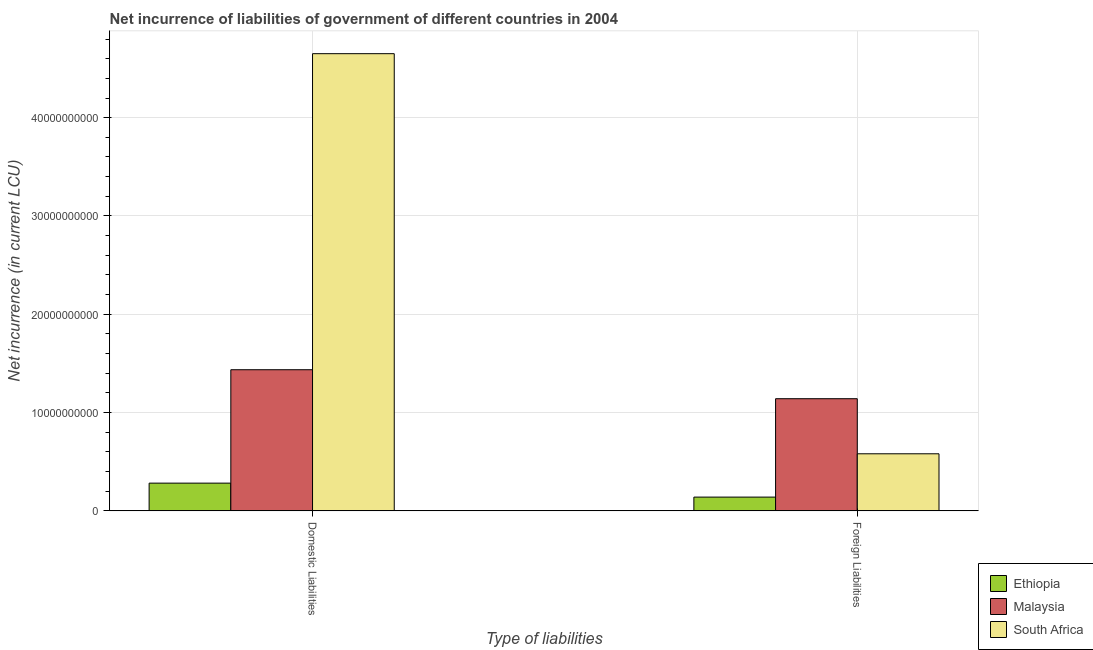How many groups of bars are there?
Give a very brief answer. 2. What is the label of the 2nd group of bars from the left?
Make the answer very short. Foreign Liabilities. What is the net incurrence of domestic liabilities in Malaysia?
Provide a succinct answer. 1.44e+1. Across all countries, what is the maximum net incurrence of foreign liabilities?
Your response must be concise. 1.14e+1. Across all countries, what is the minimum net incurrence of foreign liabilities?
Ensure brevity in your answer.  1.40e+09. In which country was the net incurrence of domestic liabilities maximum?
Offer a terse response. South Africa. In which country was the net incurrence of foreign liabilities minimum?
Provide a short and direct response. Ethiopia. What is the total net incurrence of domestic liabilities in the graph?
Your answer should be very brief. 6.37e+1. What is the difference between the net incurrence of domestic liabilities in Malaysia and that in Ethiopia?
Make the answer very short. 1.15e+1. What is the difference between the net incurrence of foreign liabilities in Ethiopia and the net incurrence of domestic liabilities in South Africa?
Give a very brief answer. -4.51e+1. What is the average net incurrence of domestic liabilities per country?
Your answer should be very brief. 2.12e+1. What is the difference between the net incurrence of domestic liabilities and net incurrence of foreign liabilities in Malaysia?
Keep it short and to the point. 2.95e+09. In how many countries, is the net incurrence of foreign liabilities greater than 14000000000 LCU?
Provide a short and direct response. 0. What is the ratio of the net incurrence of domestic liabilities in Ethiopia to that in Malaysia?
Keep it short and to the point. 0.2. In how many countries, is the net incurrence of domestic liabilities greater than the average net incurrence of domestic liabilities taken over all countries?
Provide a short and direct response. 1. What does the 1st bar from the left in Foreign Liabilities represents?
Your answer should be compact. Ethiopia. What does the 1st bar from the right in Foreign Liabilities represents?
Make the answer very short. South Africa. How many countries are there in the graph?
Offer a very short reply. 3. Does the graph contain grids?
Provide a succinct answer. Yes. Where does the legend appear in the graph?
Provide a succinct answer. Bottom right. How are the legend labels stacked?
Keep it short and to the point. Vertical. What is the title of the graph?
Provide a succinct answer. Net incurrence of liabilities of government of different countries in 2004. What is the label or title of the X-axis?
Your response must be concise. Type of liabilities. What is the label or title of the Y-axis?
Your answer should be very brief. Net incurrence (in current LCU). What is the Net incurrence (in current LCU) in Ethiopia in Domestic Liabilities?
Ensure brevity in your answer.  2.82e+09. What is the Net incurrence (in current LCU) of Malaysia in Domestic Liabilities?
Provide a short and direct response. 1.44e+1. What is the Net incurrence (in current LCU) in South Africa in Domestic Liabilities?
Provide a short and direct response. 4.65e+1. What is the Net incurrence (in current LCU) of Ethiopia in Foreign Liabilities?
Offer a terse response. 1.40e+09. What is the Net incurrence (in current LCU) in Malaysia in Foreign Liabilities?
Your response must be concise. 1.14e+1. What is the Net incurrence (in current LCU) in South Africa in Foreign Liabilities?
Your response must be concise. 5.81e+09. Across all Type of liabilities, what is the maximum Net incurrence (in current LCU) in Ethiopia?
Provide a short and direct response. 2.82e+09. Across all Type of liabilities, what is the maximum Net incurrence (in current LCU) of Malaysia?
Give a very brief answer. 1.44e+1. Across all Type of liabilities, what is the maximum Net incurrence (in current LCU) of South Africa?
Your response must be concise. 4.65e+1. Across all Type of liabilities, what is the minimum Net incurrence (in current LCU) of Ethiopia?
Your answer should be compact. 1.40e+09. Across all Type of liabilities, what is the minimum Net incurrence (in current LCU) of Malaysia?
Your response must be concise. 1.14e+1. Across all Type of liabilities, what is the minimum Net incurrence (in current LCU) of South Africa?
Make the answer very short. 5.81e+09. What is the total Net incurrence (in current LCU) in Ethiopia in the graph?
Offer a very short reply. 4.23e+09. What is the total Net incurrence (in current LCU) of Malaysia in the graph?
Provide a short and direct response. 2.58e+1. What is the total Net incurrence (in current LCU) in South Africa in the graph?
Give a very brief answer. 5.23e+1. What is the difference between the Net incurrence (in current LCU) of Ethiopia in Domestic Liabilities and that in Foreign Liabilities?
Provide a short and direct response. 1.42e+09. What is the difference between the Net incurrence (in current LCU) of Malaysia in Domestic Liabilities and that in Foreign Liabilities?
Your response must be concise. 2.95e+09. What is the difference between the Net incurrence (in current LCU) of South Africa in Domestic Liabilities and that in Foreign Liabilities?
Offer a very short reply. 4.07e+1. What is the difference between the Net incurrence (in current LCU) in Ethiopia in Domestic Liabilities and the Net incurrence (in current LCU) in Malaysia in Foreign Liabilities?
Your answer should be very brief. -8.59e+09. What is the difference between the Net incurrence (in current LCU) of Ethiopia in Domestic Liabilities and the Net incurrence (in current LCU) of South Africa in Foreign Liabilities?
Make the answer very short. -2.98e+09. What is the difference between the Net incurrence (in current LCU) of Malaysia in Domestic Liabilities and the Net incurrence (in current LCU) of South Africa in Foreign Liabilities?
Your response must be concise. 8.55e+09. What is the average Net incurrence (in current LCU) of Ethiopia per Type of liabilities?
Offer a very short reply. 2.11e+09. What is the average Net incurrence (in current LCU) in Malaysia per Type of liabilities?
Offer a very short reply. 1.29e+1. What is the average Net incurrence (in current LCU) of South Africa per Type of liabilities?
Provide a short and direct response. 2.62e+1. What is the difference between the Net incurrence (in current LCU) of Ethiopia and Net incurrence (in current LCU) of Malaysia in Domestic Liabilities?
Make the answer very short. -1.15e+1. What is the difference between the Net incurrence (in current LCU) in Ethiopia and Net incurrence (in current LCU) in South Africa in Domestic Liabilities?
Your answer should be very brief. -4.37e+1. What is the difference between the Net incurrence (in current LCU) in Malaysia and Net incurrence (in current LCU) in South Africa in Domestic Liabilities?
Keep it short and to the point. -3.21e+1. What is the difference between the Net incurrence (in current LCU) of Ethiopia and Net incurrence (in current LCU) of Malaysia in Foreign Liabilities?
Make the answer very short. -1.00e+1. What is the difference between the Net incurrence (in current LCU) in Ethiopia and Net incurrence (in current LCU) in South Africa in Foreign Liabilities?
Provide a succinct answer. -4.41e+09. What is the difference between the Net incurrence (in current LCU) of Malaysia and Net incurrence (in current LCU) of South Africa in Foreign Liabilities?
Your answer should be compact. 5.60e+09. What is the ratio of the Net incurrence (in current LCU) of Ethiopia in Domestic Liabilities to that in Foreign Liabilities?
Provide a succinct answer. 2.01. What is the ratio of the Net incurrence (in current LCU) of Malaysia in Domestic Liabilities to that in Foreign Liabilities?
Offer a terse response. 1.26. What is the ratio of the Net incurrence (in current LCU) in South Africa in Domestic Liabilities to that in Foreign Liabilities?
Provide a short and direct response. 8.01. What is the difference between the highest and the second highest Net incurrence (in current LCU) of Ethiopia?
Keep it short and to the point. 1.42e+09. What is the difference between the highest and the second highest Net incurrence (in current LCU) in Malaysia?
Give a very brief answer. 2.95e+09. What is the difference between the highest and the second highest Net incurrence (in current LCU) of South Africa?
Your answer should be compact. 4.07e+1. What is the difference between the highest and the lowest Net incurrence (in current LCU) in Ethiopia?
Keep it short and to the point. 1.42e+09. What is the difference between the highest and the lowest Net incurrence (in current LCU) of Malaysia?
Provide a succinct answer. 2.95e+09. What is the difference between the highest and the lowest Net incurrence (in current LCU) of South Africa?
Your answer should be very brief. 4.07e+1. 